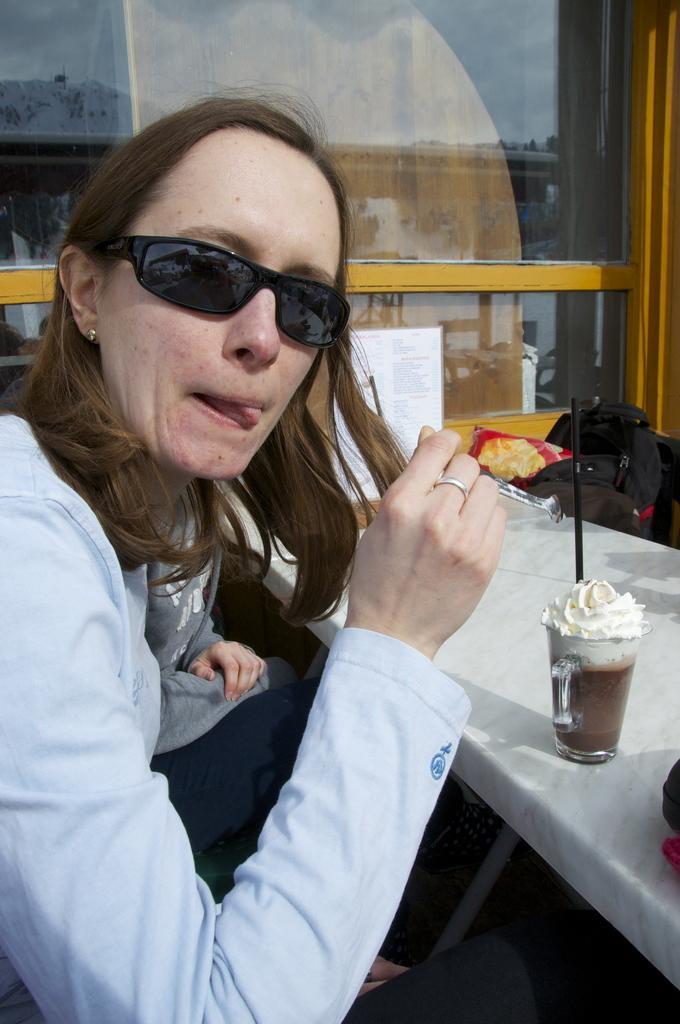In one or two sentences, can you explain what this image depicts? A beautiful is eating an ice cream. She wore a dress, there is an ice cream glass on this table. 